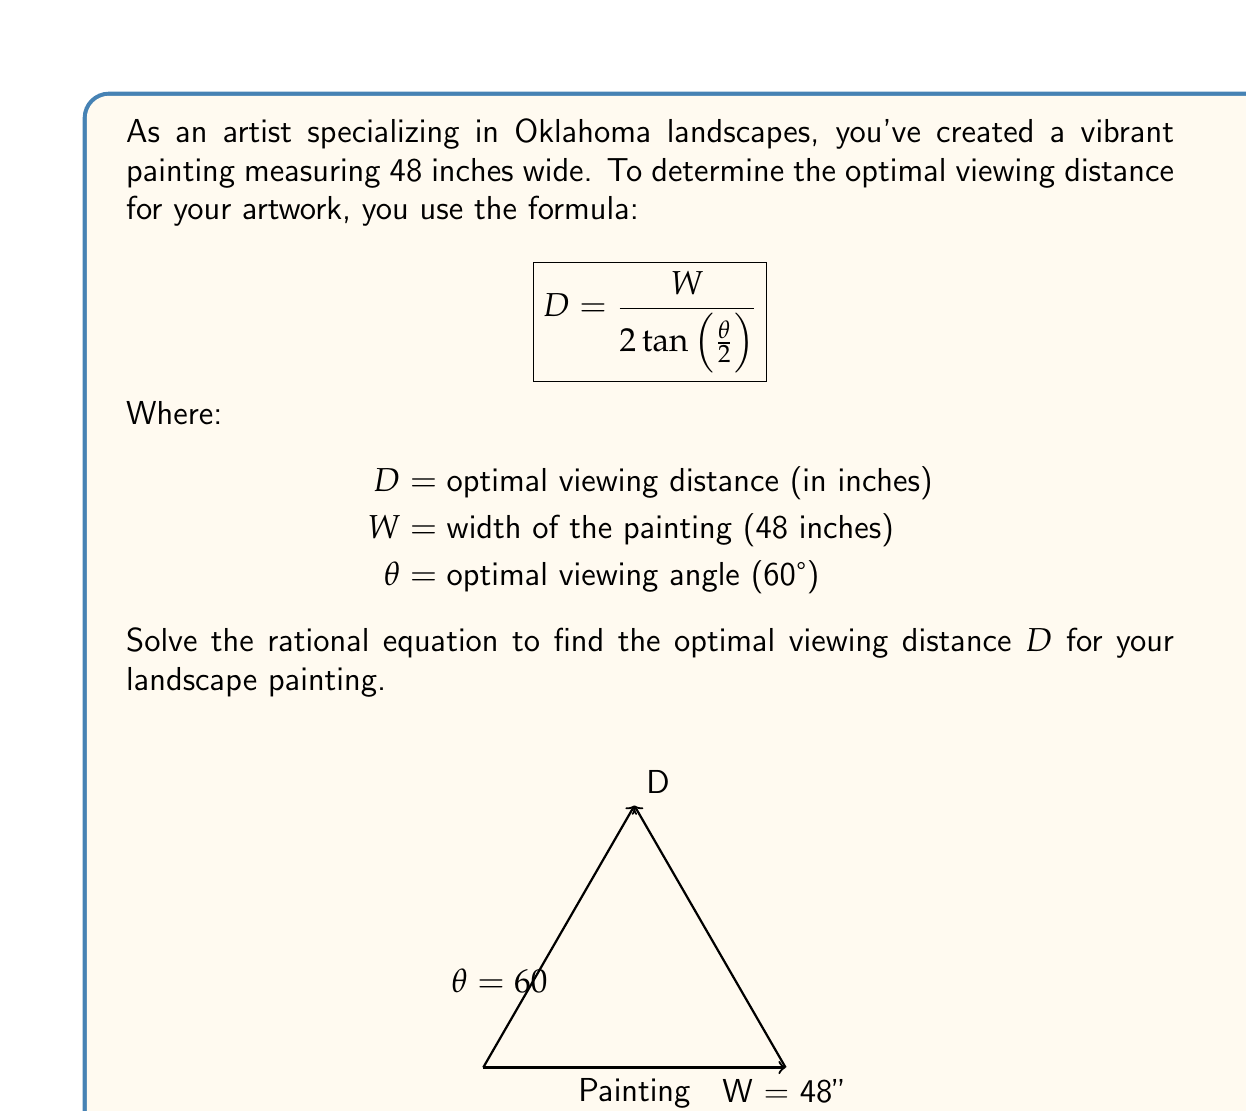Could you help me with this problem? Let's solve this step-by-step:

1) We start with the given formula:
   $$D = \frac{W}{2 \tan(\frac{\theta}{2})}$$

2) We know that $W = 48$ inches and $\theta = 60°$. Let's substitute these values:
   $$D = \frac{48}{2 \tan(\frac{60°}{2})}$$

3) Simplify the angle in the tangent function:
   $$D = \frac{48}{2 \tan(30°)}$$

4) Recall that $\tan(30°) = \frac{1}{\sqrt{3}}$. Let's substitute this:
   $$D = \frac{48}{2 \cdot \frac{1}{\sqrt{3}}}$$

5) Simplify the fraction:
   $$D = \frac{48 \cdot \sqrt{3}}{2}$$

6) Multiply:
   $$D = 24\sqrt{3}$$

7) To get a decimal approximation, we can calculate this:
   $$D \approx 24 \cdot 1.732 \approx 41.57$$

Therefore, the optimal viewing distance is approximately 41.57 inches or exactly $24\sqrt{3}$ inches.
Answer: $24\sqrt{3}$ inches 